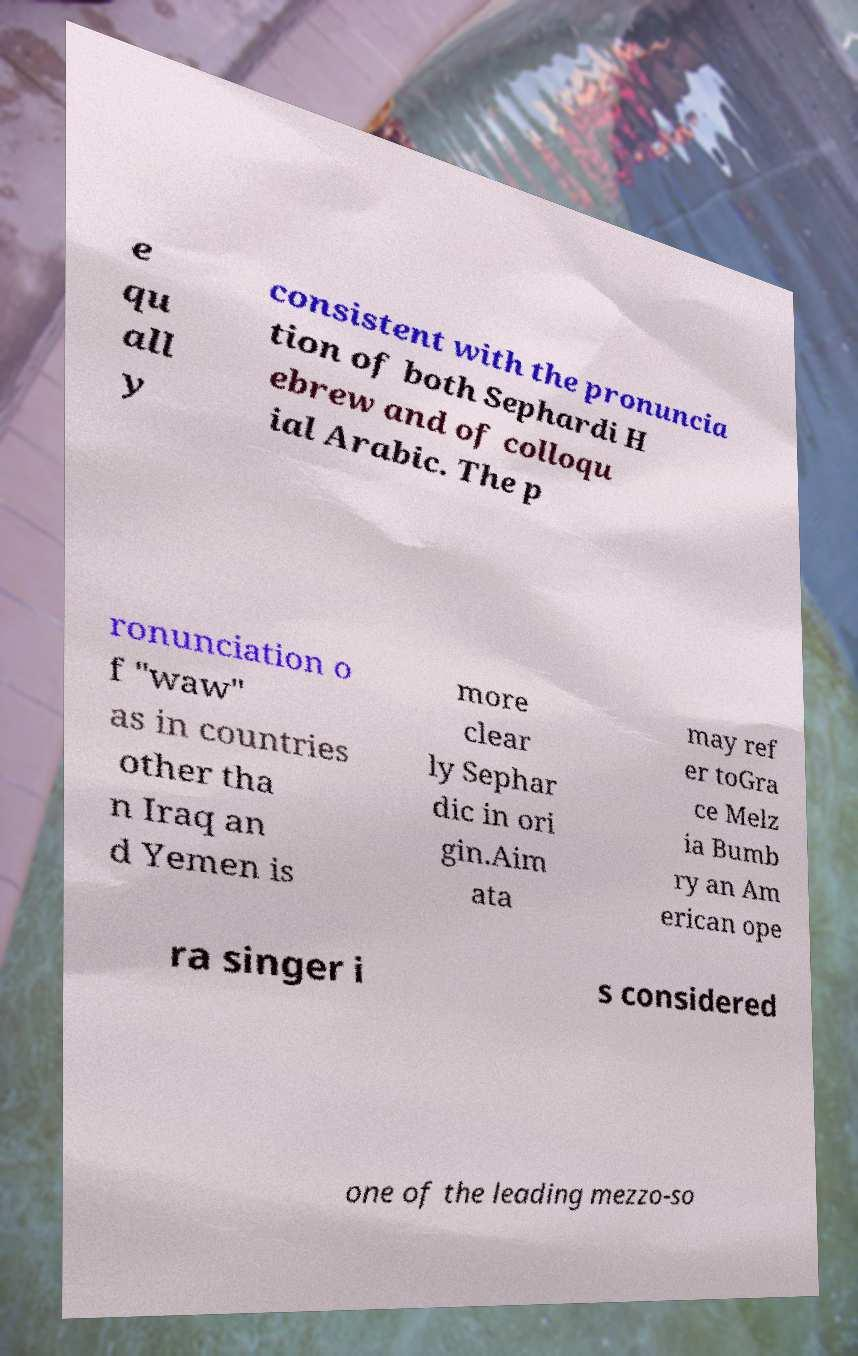Could you assist in decoding the text presented in this image and type it out clearly? e qu all y consistent with the pronuncia tion of both Sephardi H ebrew and of colloqu ial Arabic. The p ronunciation o f "waw" as in countries other tha n Iraq an d Yemen is more clear ly Sephar dic in ori gin.Aim ata may ref er toGra ce Melz ia Bumb ry an Am erican ope ra singer i s considered one of the leading mezzo-so 